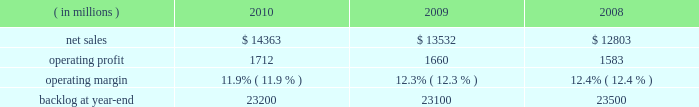Operating profit for the segment increased 10% ( 10 % ) in 2009 compared to 2008 .
The growth in operating profit primarily was due to increases in air mobility and other aeronautics programs .
The $ 70 million increase in air mobility 2019s operating profit primarily was due to the higher volume on c-130j deliveries and c-130 support programs .
In other aeronautics programs , operating profit increased $ 120 million , which mainly was attributable to improved performance in sustainment activities and higher volume on p-3 programs .
Additionally , the increase in operating profit included the favorable restructuring of a p-3 modification contract in 2009 .
Combat aircraft 2019s operating profit decreased $ 22 million during the year primarily due to a reduction in the level of favorable performance adjustments on f-16 programs in 2009 compared to 2008 and lower volume on other combat aircraft programs .
These decreases more than offset increased operating profit resulting from higher volume and improved performance on the f-35 program and an increase in the level of favorable performance adjustments on the f-22 program in 2009 compared to 2008 .
The remaining change in operating profit is attributable to a decrease in other income , net , between the comparable periods .
Backlog increased in 2010 compared to 2009 mainly due to orders exceeding sales on the c-130j , f-35 and c-5 programs , which partially were offset by higher sales volume compared to new orders on the f-22 program in 2010 .
Backlog decreased in 2009 compared to 2008 mainly due to sales exceeding orders on the f-22 and f-35 programs , which partially were offset by orders exceeding sales on the c-130j and c-5 programs .
We expect aeronautics will have sales growth in the upper single digit percentage range for 2011 as compared to 2010 .
This increase primarily is driven by growth on f-35 low rate initial production ( lrip ) contracts , c-130j and c-5 rerp programs that will more than offset a decline on the f-22 program .
Operating profit is projected to increase at a mid single digit percentage rate above 2010 levels , resulting in a decline in operating margins between the years .
Similar to the relationship of operating margins from 2009 to 2010 discussed above , the expected operating margin decrease from 2010 to 2011 reflects the trend of aeronautics performing more development and initial production work on the f-35 program and is performing less work on more mature programs such as the f-22 and f-16 , even though sales are expected to increase in 2011 relative to 2010 .
Electronic systems our electronic systems business segment manages complex programs and designs , develops , produces , and integrates hardware and software solutions to ensure the mission readiness of armed forces and government agencies worldwide .
The segment 2019s three lines of business are mission systems & sensors ( ms2 ) , missiles & fire control ( m&fc ) , and global training & logistics ( gt&l ) .
With such a broad portfolio of programs to provide products and services , many of its activities involve a combination of both development and production contracts with varying delivery schedules .
Some of its more significant programs , including the thaad system , the aegis weapon system , and the littoral combat ship program , demonstrate the diverse products and services electronic systems provides .
Electronic systems 2019 operating results included the following : ( in millions ) 2010 2009 2008 .
Net sales for electronic systems increased by 6% ( 6 % ) in 2010 compared to 2009 .
Sales increased in all three lines of business during the year .
The $ 421 million increase at gt&l primarily was due to growth on readiness and stability operations , which partially was offset by lower volume on simulation & training programs .
The $ 316 million increase at m&fc primarily was due to higher volume on tactical missile and air defense programs , which partially was offset by a decline in volume on fire control systems .
The $ 94 million increase at ms2 mainly was due to higher volume on surface naval warfare , ship & aviation systems , and radar systems programs , which partially was offset by lower volume on undersea warfare programs .
Net sales for electronic systems increased by 6% ( 6 % ) in 2009 compared to 2008 .
Sales increases in m&fc and gt&l more than offset a decline in ms2 .
The $ 429 million increase in sales at m&fc primarily was due to growth on tactical missile programs and fire control systems .
The $ 355 million increase at gt&l primarily was due to growth on simulation and training activities and readiness and stability operations .
The increase in simulation and training also included sales from the first quarter 2009 acquisition of universal systems and technology , inc .
The $ 55 million decrease at ms2 mainly was due to lower volume on ship & aviation systems and undersea warfare programs , which partially were offset by higher volume on radar systems and surface naval warfare programs. .
What are the total operating expenses in 2009? 
Computations: (13532 - 1660)
Answer: 11872.0. 